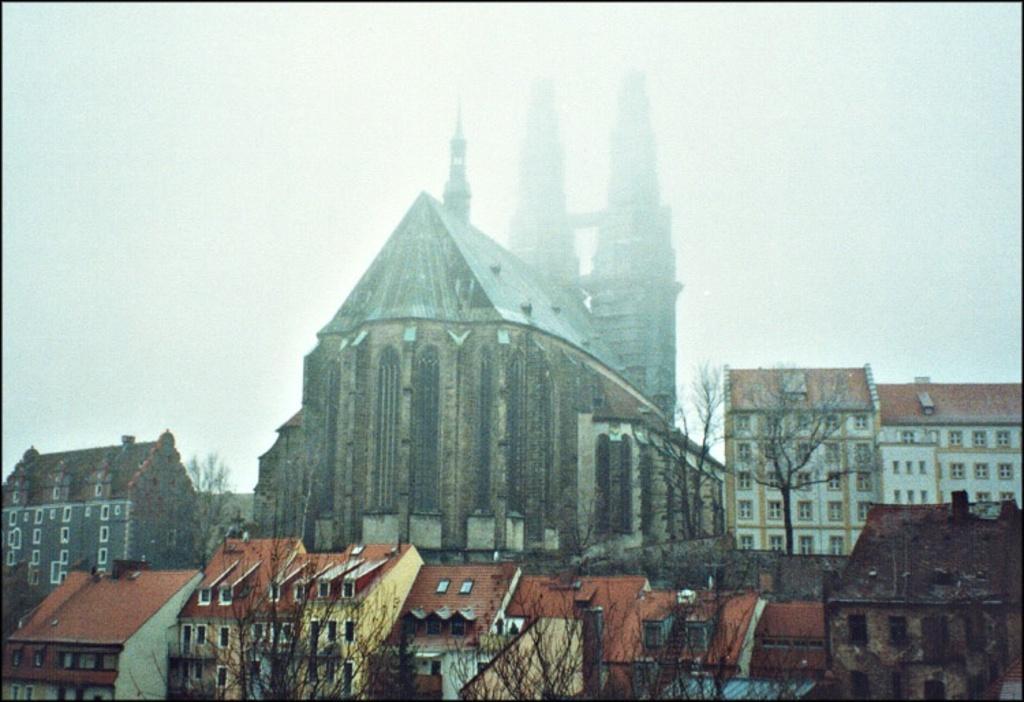In one or two sentences, can you explain what this image depicts? In this picture there are buildings in the image and there are trees at the bottom side of the image. 